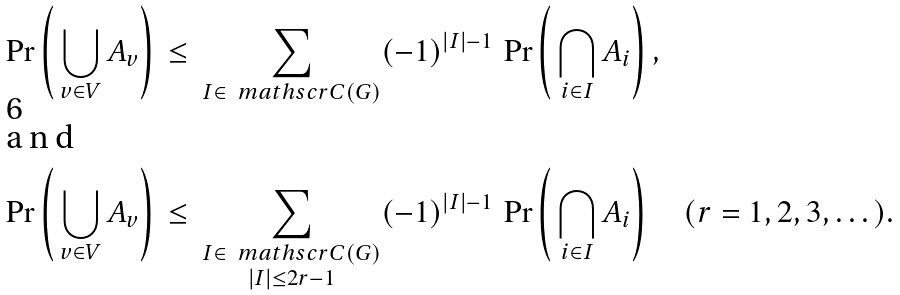<formula> <loc_0><loc_0><loc_500><loc_500>\Pr \left ( \, \bigcup _ { v \in V } A _ { v } \right ) & \, \leq \, \sum _ { I \in \, \ m a t h s c r { C } ( G ) } ( - 1 ) ^ { | I | - 1 } \, \Pr \left ( \, \bigcap _ { i \in I } A _ { i } \right ) , \\ \intertext { a n d } \Pr \left ( \, \bigcup _ { v \in V } A _ { v } \right ) & \, \leq \, \sum _ { \substack { I \in \, \ m a t h s c r { C } ( G ) \\ | I | \leq 2 r - 1 } } ( - 1 ) ^ { | I | - 1 } \, \Pr \left ( \, \bigcap _ { i \in I } A _ { i } \right ) \quad ( r = 1 , 2 , 3 , \dots ) .</formula> 